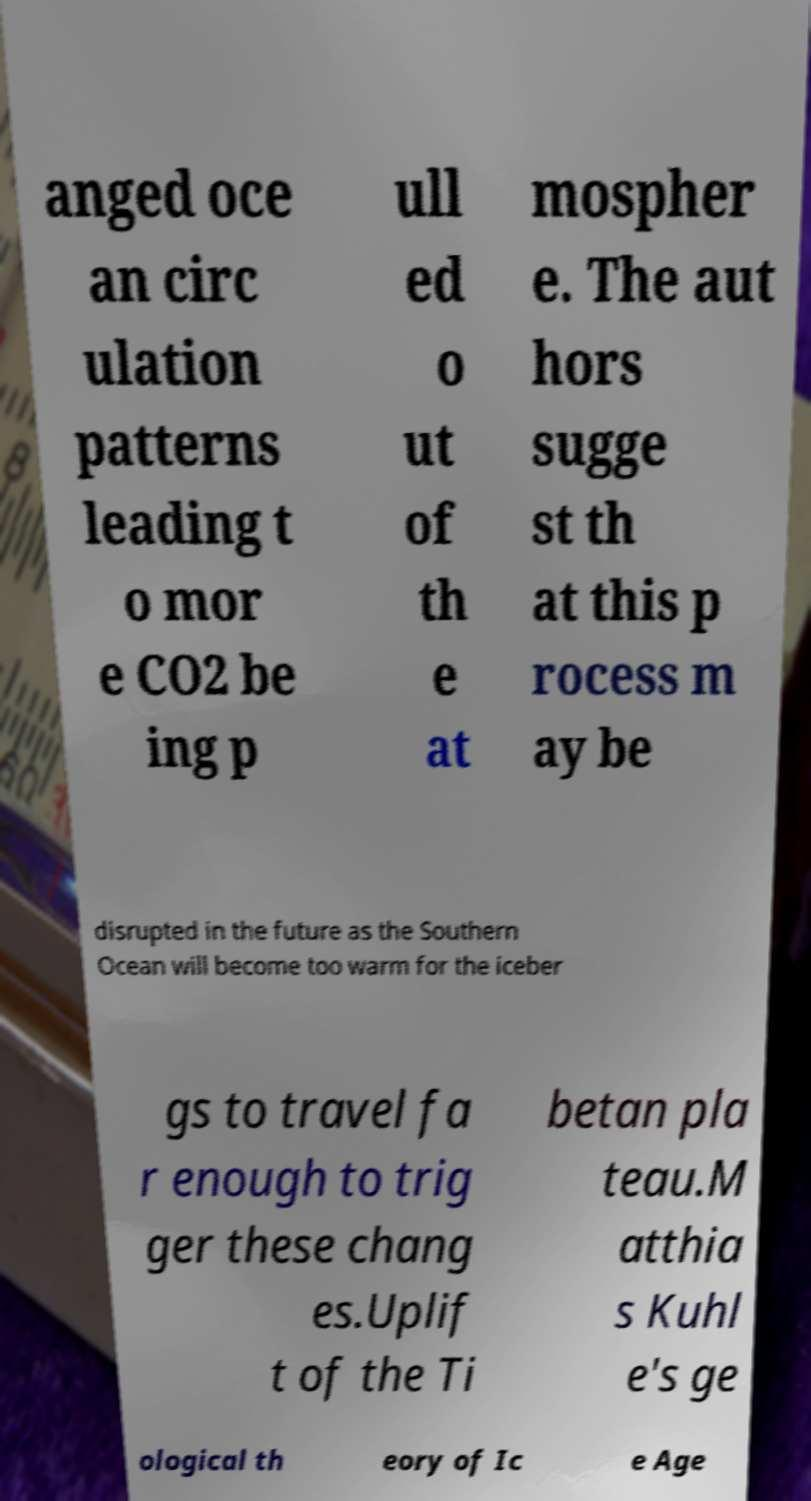I need the written content from this picture converted into text. Can you do that? anged oce an circ ulation patterns leading t o mor e CO2 be ing p ull ed o ut of th e at mospher e. The aut hors sugge st th at this p rocess m ay be disrupted in the future as the Southern Ocean will become too warm for the iceber gs to travel fa r enough to trig ger these chang es.Uplif t of the Ti betan pla teau.M atthia s Kuhl e's ge ological th eory of Ic e Age 